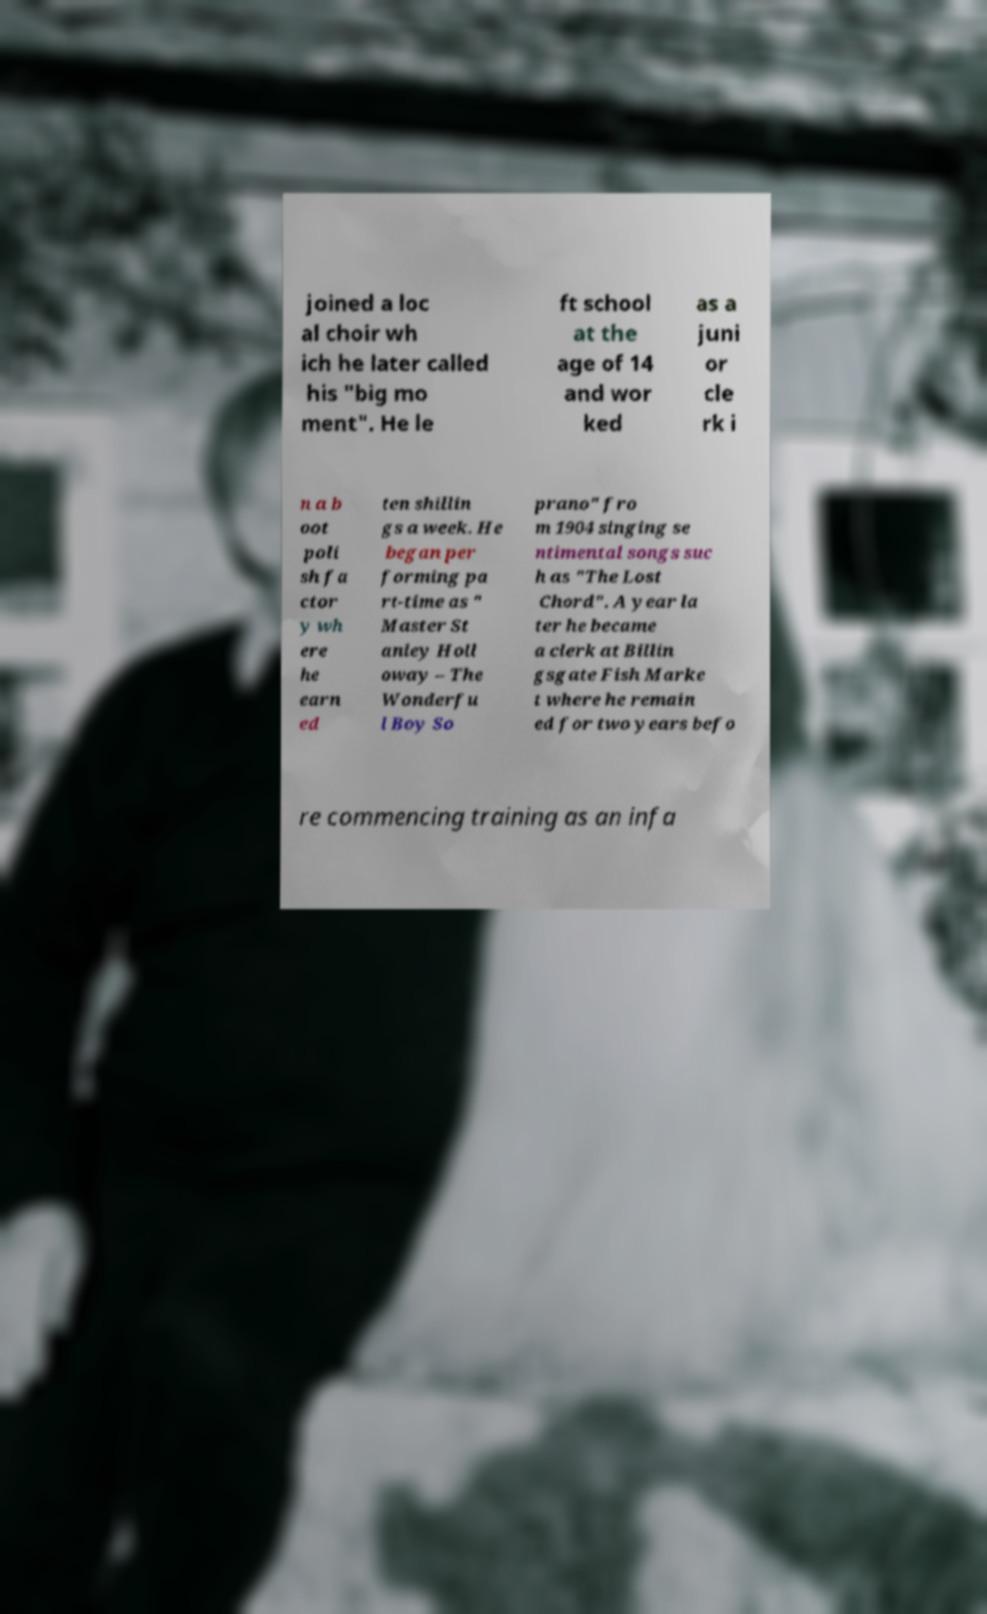There's text embedded in this image that I need extracted. Can you transcribe it verbatim? joined a loc al choir wh ich he later called his "big mo ment". He le ft school at the age of 14 and wor ked as a juni or cle rk i n a b oot poli sh fa ctor y wh ere he earn ed ten shillin gs a week. He began per forming pa rt-time as " Master St anley Holl oway – The Wonderfu l Boy So prano" fro m 1904 singing se ntimental songs suc h as "The Lost Chord". A year la ter he became a clerk at Billin gsgate Fish Marke t where he remain ed for two years befo re commencing training as an infa 